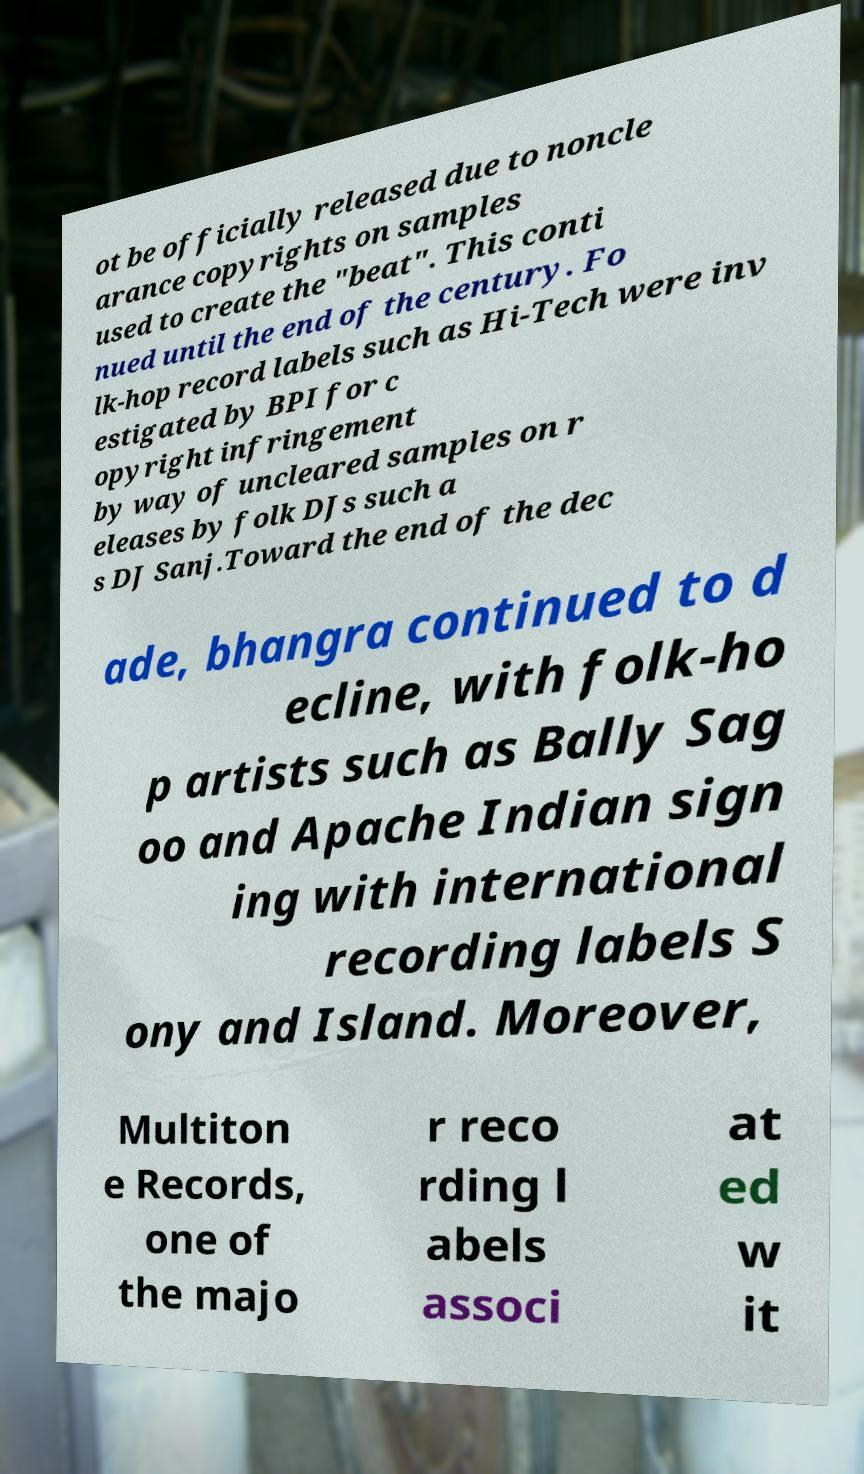Can you read and provide the text displayed in the image?This photo seems to have some interesting text. Can you extract and type it out for me? ot be officially released due to noncle arance copyrights on samples used to create the "beat". This conti nued until the end of the century. Fo lk-hop record labels such as Hi-Tech were inv estigated by BPI for c opyright infringement by way of uncleared samples on r eleases by folk DJs such a s DJ Sanj.Toward the end of the dec ade, bhangra continued to d ecline, with folk-ho p artists such as Bally Sag oo and Apache Indian sign ing with international recording labels S ony and Island. Moreover, Multiton e Records, one of the majo r reco rding l abels associ at ed w it 